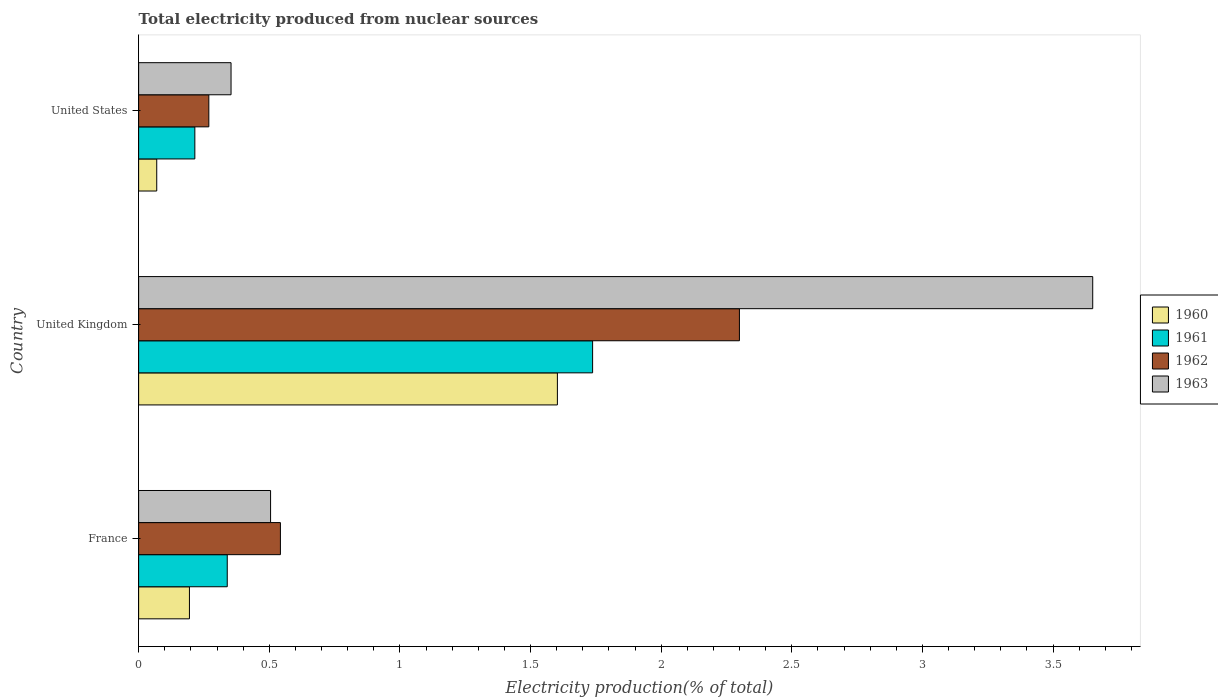How many different coloured bars are there?
Keep it short and to the point. 4. How many groups of bars are there?
Give a very brief answer. 3. Are the number of bars per tick equal to the number of legend labels?
Offer a very short reply. Yes. Are the number of bars on each tick of the Y-axis equal?
Provide a succinct answer. Yes. What is the label of the 1st group of bars from the top?
Your response must be concise. United States. In how many cases, is the number of bars for a given country not equal to the number of legend labels?
Your answer should be very brief. 0. What is the total electricity produced in 1962 in France?
Your response must be concise. 0.54. Across all countries, what is the maximum total electricity produced in 1961?
Provide a succinct answer. 1.74. Across all countries, what is the minimum total electricity produced in 1962?
Your answer should be very brief. 0.27. In which country was the total electricity produced in 1962 maximum?
Your answer should be compact. United Kingdom. In which country was the total electricity produced in 1963 minimum?
Your answer should be compact. United States. What is the total total electricity produced in 1962 in the graph?
Give a very brief answer. 3.11. What is the difference between the total electricity produced in 1962 in France and that in United Kingdom?
Provide a succinct answer. -1.76. What is the difference between the total electricity produced in 1961 in United States and the total electricity produced in 1962 in France?
Your answer should be very brief. -0.33. What is the average total electricity produced in 1963 per country?
Give a very brief answer. 1.5. What is the difference between the total electricity produced in 1960 and total electricity produced in 1961 in United Kingdom?
Make the answer very short. -0.13. What is the ratio of the total electricity produced in 1963 in United Kingdom to that in United States?
Your answer should be very brief. 10.32. What is the difference between the highest and the second highest total electricity produced in 1962?
Offer a very short reply. 1.76. What is the difference between the highest and the lowest total electricity produced in 1961?
Give a very brief answer. 1.52. In how many countries, is the total electricity produced in 1963 greater than the average total electricity produced in 1963 taken over all countries?
Give a very brief answer. 1. Is it the case that in every country, the sum of the total electricity produced in 1960 and total electricity produced in 1963 is greater than the sum of total electricity produced in 1961 and total electricity produced in 1962?
Offer a terse response. No. What does the 4th bar from the top in France represents?
Provide a succinct answer. 1960. How many countries are there in the graph?
Provide a short and direct response. 3. What is the difference between two consecutive major ticks on the X-axis?
Keep it short and to the point. 0.5. Are the values on the major ticks of X-axis written in scientific E-notation?
Make the answer very short. No. Where does the legend appear in the graph?
Your answer should be very brief. Center right. How are the legend labels stacked?
Keep it short and to the point. Vertical. What is the title of the graph?
Provide a short and direct response. Total electricity produced from nuclear sources. Does "1960" appear as one of the legend labels in the graph?
Ensure brevity in your answer.  Yes. What is the label or title of the Y-axis?
Your answer should be compact. Country. What is the Electricity production(% of total) in 1960 in France?
Keep it short and to the point. 0.19. What is the Electricity production(% of total) in 1961 in France?
Ensure brevity in your answer.  0.34. What is the Electricity production(% of total) in 1962 in France?
Provide a short and direct response. 0.54. What is the Electricity production(% of total) of 1963 in France?
Make the answer very short. 0.51. What is the Electricity production(% of total) in 1960 in United Kingdom?
Give a very brief answer. 1.6. What is the Electricity production(% of total) in 1961 in United Kingdom?
Your answer should be very brief. 1.74. What is the Electricity production(% of total) in 1962 in United Kingdom?
Your response must be concise. 2.3. What is the Electricity production(% of total) of 1963 in United Kingdom?
Offer a terse response. 3.65. What is the Electricity production(% of total) of 1960 in United States?
Make the answer very short. 0.07. What is the Electricity production(% of total) of 1961 in United States?
Ensure brevity in your answer.  0.22. What is the Electricity production(% of total) of 1962 in United States?
Provide a short and direct response. 0.27. What is the Electricity production(% of total) of 1963 in United States?
Your response must be concise. 0.35. Across all countries, what is the maximum Electricity production(% of total) of 1960?
Your answer should be very brief. 1.6. Across all countries, what is the maximum Electricity production(% of total) in 1961?
Offer a terse response. 1.74. Across all countries, what is the maximum Electricity production(% of total) of 1962?
Keep it short and to the point. 2.3. Across all countries, what is the maximum Electricity production(% of total) of 1963?
Keep it short and to the point. 3.65. Across all countries, what is the minimum Electricity production(% of total) of 1960?
Your response must be concise. 0.07. Across all countries, what is the minimum Electricity production(% of total) of 1961?
Your response must be concise. 0.22. Across all countries, what is the minimum Electricity production(% of total) of 1962?
Your response must be concise. 0.27. Across all countries, what is the minimum Electricity production(% of total) in 1963?
Offer a terse response. 0.35. What is the total Electricity production(% of total) in 1960 in the graph?
Keep it short and to the point. 1.87. What is the total Electricity production(% of total) of 1961 in the graph?
Provide a succinct answer. 2.29. What is the total Electricity production(% of total) of 1962 in the graph?
Make the answer very short. 3.11. What is the total Electricity production(% of total) in 1963 in the graph?
Your answer should be compact. 4.51. What is the difference between the Electricity production(% of total) of 1960 in France and that in United Kingdom?
Your answer should be compact. -1.41. What is the difference between the Electricity production(% of total) in 1961 in France and that in United Kingdom?
Keep it short and to the point. -1.4. What is the difference between the Electricity production(% of total) in 1962 in France and that in United Kingdom?
Give a very brief answer. -1.76. What is the difference between the Electricity production(% of total) of 1963 in France and that in United Kingdom?
Make the answer very short. -3.15. What is the difference between the Electricity production(% of total) in 1960 in France and that in United States?
Make the answer very short. 0.13. What is the difference between the Electricity production(% of total) of 1961 in France and that in United States?
Your answer should be very brief. 0.12. What is the difference between the Electricity production(% of total) of 1962 in France and that in United States?
Offer a very short reply. 0.27. What is the difference between the Electricity production(% of total) in 1963 in France and that in United States?
Keep it short and to the point. 0.15. What is the difference between the Electricity production(% of total) of 1960 in United Kingdom and that in United States?
Your answer should be very brief. 1.53. What is the difference between the Electricity production(% of total) of 1961 in United Kingdom and that in United States?
Your response must be concise. 1.52. What is the difference between the Electricity production(% of total) in 1962 in United Kingdom and that in United States?
Keep it short and to the point. 2.03. What is the difference between the Electricity production(% of total) of 1963 in United Kingdom and that in United States?
Offer a terse response. 3.3. What is the difference between the Electricity production(% of total) in 1960 in France and the Electricity production(% of total) in 1961 in United Kingdom?
Your answer should be compact. -1.54. What is the difference between the Electricity production(% of total) in 1960 in France and the Electricity production(% of total) in 1962 in United Kingdom?
Your answer should be compact. -2.11. What is the difference between the Electricity production(% of total) of 1960 in France and the Electricity production(% of total) of 1963 in United Kingdom?
Offer a very short reply. -3.46. What is the difference between the Electricity production(% of total) in 1961 in France and the Electricity production(% of total) in 1962 in United Kingdom?
Provide a succinct answer. -1.96. What is the difference between the Electricity production(% of total) of 1961 in France and the Electricity production(% of total) of 1963 in United Kingdom?
Provide a succinct answer. -3.31. What is the difference between the Electricity production(% of total) of 1962 in France and the Electricity production(% of total) of 1963 in United Kingdom?
Your response must be concise. -3.11. What is the difference between the Electricity production(% of total) of 1960 in France and the Electricity production(% of total) of 1961 in United States?
Make the answer very short. -0.02. What is the difference between the Electricity production(% of total) in 1960 in France and the Electricity production(% of total) in 1962 in United States?
Make the answer very short. -0.07. What is the difference between the Electricity production(% of total) of 1960 in France and the Electricity production(% of total) of 1963 in United States?
Give a very brief answer. -0.16. What is the difference between the Electricity production(% of total) of 1961 in France and the Electricity production(% of total) of 1962 in United States?
Your answer should be compact. 0.07. What is the difference between the Electricity production(% of total) in 1961 in France and the Electricity production(% of total) in 1963 in United States?
Your answer should be compact. -0.01. What is the difference between the Electricity production(% of total) of 1962 in France and the Electricity production(% of total) of 1963 in United States?
Provide a short and direct response. 0.19. What is the difference between the Electricity production(% of total) in 1960 in United Kingdom and the Electricity production(% of total) in 1961 in United States?
Offer a terse response. 1.39. What is the difference between the Electricity production(% of total) in 1960 in United Kingdom and the Electricity production(% of total) in 1962 in United States?
Provide a short and direct response. 1.33. What is the difference between the Electricity production(% of total) in 1960 in United Kingdom and the Electricity production(% of total) in 1963 in United States?
Provide a succinct answer. 1.25. What is the difference between the Electricity production(% of total) in 1961 in United Kingdom and the Electricity production(% of total) in 1962 in United States?
Keep it short and to the point. 1.47. What is the difference between the Electricity production(% of total) in 1961 in United Kingdom and the Electricity production(% of total) in 1963 in United States?
Offer a terse response. 1.38. What is the difference between the Electricity production(% of total) of 1962 in United Kingdom and the Electricity production(% of total) of 1963 in United States?
Your answer should be very brief. 1.95. What is the average Electricity production(% of total) of 1960 per country?
Your answer should be compact. 0.62. What is the average Electricity production(% of total) of 1961 per country?
Provide a short and direct response. 0.76. What is the average Electricity production(% of total) in 1963 per country?
Your response must be concise. 1.5. What is the difference between the Electricity production(% of total) in 1960 and Electricity production(% of total) in 1961 in France?
Provide a short and direct response. -0.14. What is the difference between the Electricity production(% of total) of 1960 and Electricity production(% of total) of 1962 in France?
Your answer should be very brief. -0.35. What is the difference between the Electricity production(% of total) in 1960 and Electricity production(% of total) in 1963 in France?
Your answer should be very brief. -0.31. What is the difference between the Electricity production(% of total) of 1961 and Electricity production(% of total) of 1962 in France?
Provide a succinct answer. -0.2. What is the difference between the Electricity production(% of total) of 1961 and Electricity production(% of total) of 1963 in France?
Provide a short and direct response. -0.17. What is the difference between the Electricity production(% of total) in 1962 and Electricity production(% of total) in 1963 in France?
Your answer should be very brief. 0.04. What is the difference between the Electricity production(% of total) of 1960 and Electricity production(% of total) of 1961 in United Kingdom?
Make the answer very short. -0.13. What is the difference between the Electricity production(% of total) in 1960 and Electricity production(% of total) in 1962 in United Kingdom?
Provide a short and direct response. -0.7. What is the difference between the Electricity production(% of total) of 1960 and Electricity production(% of total) of 1963 in United Kingdom?
Your response must be concise. -2.05. What is the difference between the Electricity production(% of total) of 1961 and Electricity production(% of total) of 1962 in United Kingdom?
Give a very brief answer. -0.56. What is the difference between the Electricity production(% of total) of 1961 and Electricity production(% of total) of 1963 in United Kingdom?
Make the answer very short. -1.91. What is the difference between the Electricity production(% of total) in 1962 and Electricity production(% of total) in 1963 in United Kingdom?
Give a very brief answer. -1.35. What is the difference between the Electricity production(% of total) in 1960 and Electricity production(% of total) in 1961 in United States?
Offer a very short reply. -0.15. What is the difference between the Electricity production(% of total) of 1960 and Electricity production(% of total) of 1962 in United States?
Ensure brevity in your answer.  -0.2. What is the difference between the Electricity production(% of total) in 1960 and Electricity production(% of total) in 1963 in United States?
Give a very brief answer. -0.28. What is the difference between the Electricity production(% of total) of 1961 and Electricity production(% of total) of 1962 in United States?
Ensure brevity in your answer.  -0.05. What is the difference between the Electricity production(% of total) of 1961 and Electricity production(% of total) of 1963 in United States?
Provide a succinct answer. -0.14. What is the difference between the Electricity production(% of total) of 1962 and Electricity production(% of total) of 1963 in United States?
Provide a succinct answer. -0.09. What is the ratio of the Electricity production(% of total) in 1960 in France to that in United Kingdom?
Keep it short and to the point. 0.12. What is the ratio of the Electricity production(% of total) in 1961 in France to that in United Kingdom?
Offer a very short reply. 0.2. What is the ratio of the Electricity production(% of total) in 1962 in France to that in United Kingdom?
Your response must be concise. 0.24. What is the ratio of the Electricity production(% of total) of 1963 in France to that in United Kingdom?
Make the answer very short. 0.14. What is the ratio of the Electricity production(% of total) in 1960 in France to that in United States?
Give a very brief answer. 2.81. What is the ratio of the Electricity production(% of total) of 1961 in France to that in United States?
Keep it short and to the point. 1.58. What is the ratio of the Electricity production(% of total) of 1962 in France to that in United States?
Offer a terse response. 2.02. What is the ratio of the Electricity production(% of total) in 1963 in France to that in United States?
Offer a very short reply. 1.43. What is the ratio of the Electricity production(% of total) of 1960 in United Kingdom to that in United States?
Your answer should be very brief. 23.14. What is the ratio of the Electricity production(% of total) in 1961 in United Kingdom to that in United States?
Provide a succinct answer. 8.08. What is the ratio of the Electricity production(% of total) in 1962 in United Kingdom to that in United States?
Offer a very short reply. 8.56. What is the ratio of the Electricity production(% of total) of 1963 in United Kingdom to that in United States?
Ensure brevity in your answer.  10.32. What is the difference between the highest and the second highest Electricity production(% of total) in 1960?
Offer a terse response. 1.41. What is the difference between the highest and the second highest Electricity production(% of total) in 1961?
Offer a terse response. 1.4. What is the difference between the highest and the second highest Electricity production(% of total) of 1962?
Provide a short and direct response. 1.76. What is the difference between the highest and the second highest Electricity production(% of total) in 1963?
Provide a succinct answer. 3.15. What is the difference between the highest and the lowest Electricity production(% of total) in 1960?
Your answer should be very brief. 1.53. What is the difference between the highest and the lowest Electricity production(% of total) in 1961?
Provide a short and direct response. 1.52. What is the difference between the highest and the lowest Electricity production(% of total) in 1962?
Provide a short and direct response. 2.03. What is the difference between the highest and the lowest Electricity production(% of total) of 1963?
Make the answer very short. 3.3. 